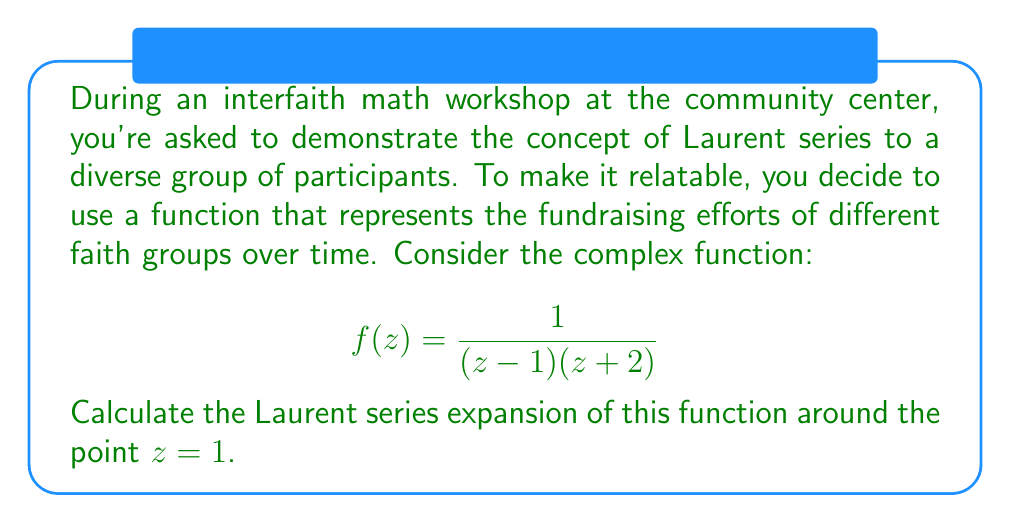Solve this math problem. Let's approach this step-by-step:

1) First, we need to identify the singularities of the function. The function has two simple poles: at $z=1$ and $z=-2$.

2) Since we're expanding around $z=1$, we'll use the general form of the Laurent series:

   $$f(z) = \sum_{n=-\infty}^{\infty} a_n(z-1)^n$$

3) To find the coefficients, we'll use partial fraction decomposition:

   $$\frac{1}{(z-1)(z+2)} = \frac{A}{z-1} + \frac{B}{z+2}$$

4) Solving for A and B:

   $$1 = A(z+2) + B(z-1)$$
   
   When $z=1$: $1 = 3A$, so $A = \frac{1}{3}$
   When $z=-2$: $1 = -3B$, so $B = -\frac{1}{3}$

5) Therefore, our function can be written as:

   $$f(z) = \frac{1/3}{z-1} - \frac{1/3}{z+2}$$

6) Now, we focus on the second term and expand it as a geometric series:

   $$-\frac{1/3}{z+2} = -\frac{1/3}{(z-1)+3} = -\frac{1/3}{3(1+\frac{z-1}{3})} = -\frac{1}{9}\cdot\frac{1}{1+\frac{z-1}{3}}$$

   $$= -\frac{1}{9}\left(1 - \frac{z-1}{3} + \frac{(z-1)^2}{9} - \frac{(z-1)^3}{27} + ...\right)$$

7) Combining this with the first term:

   $$f(z) = \frac{1/3}{z-1} - \frac{1}{9} + \frac{1}{27}(z-1) - \frac{1}{81}(z-1)^2 + \frac{1}{243}(z-1)^3 - ...$$

This is the Laurent series expansion of $f(z)$ around $z=1$.
Answer: The Laurent series expansion of $f(z) = \frac{1}{(z-1)(z+2)}$ around $z=1$ is:

$$f(z) = \frac{1/3}{z-1} - \frac{1}{9} + \frac{1}{27}(z-1) - \frac{1}{81}(z-1)^2 + \frac{1}{243}(z-1)^3 + ...$$

or more formally:

$$f(z) = \frac{1/3}{z-1} + \sum_{n=0}^{\infty} (-1)^{n+1}\frac{1}{3^{n+2}}(z-1)^n$$ 